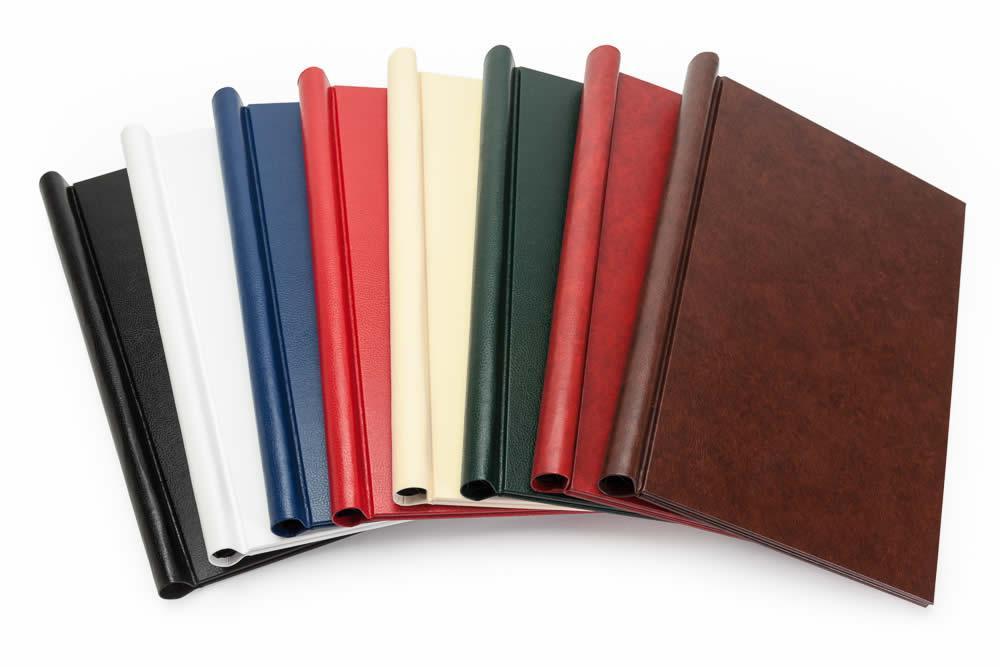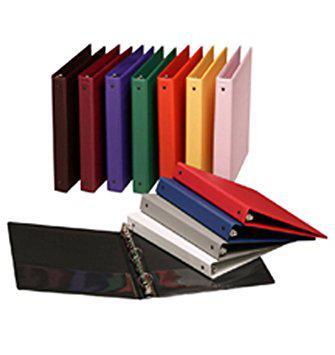The first image is the image on the left, the second image is the image on the right. Analyze the images presented: Is the assertion "One image shows overlapping binders of different solid colors arranged in a single curved, arching line." valid? Answer yes or no. Yes. 